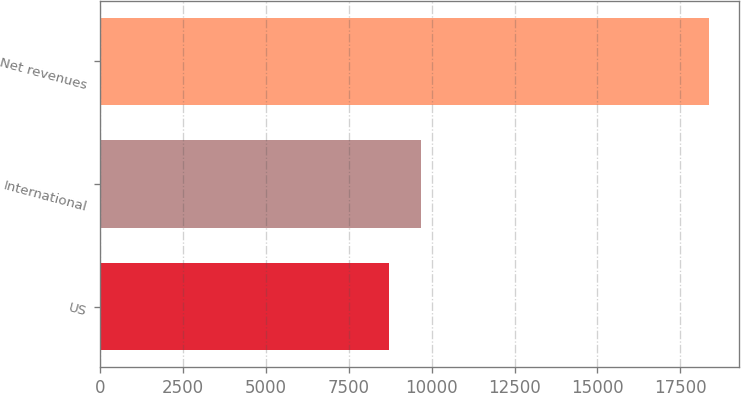Convert chart to OTSL. <chart><loc_0><loc_0><loc_500><loc_500><bar_chart><fcel>US<fcel>International<fcel>Net revenues<nl><fcel>8704<fcel>9669.4<fcel>18358<nl></chart> 